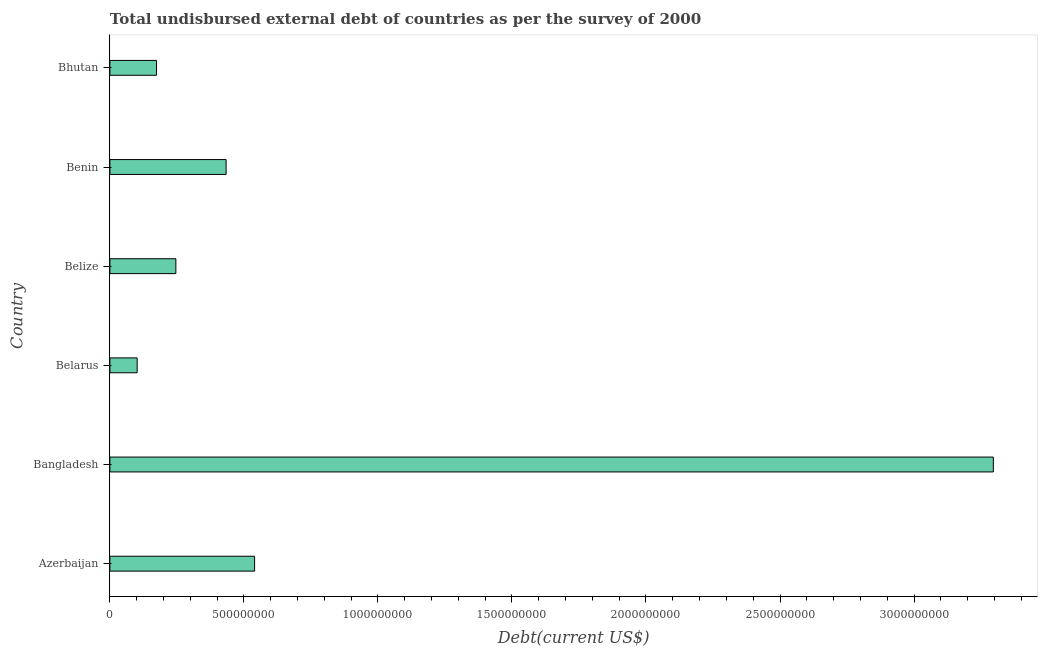What is the title of the graph?
Make the answer very short. Total undisbursed external debt of countries as per the survey of 2000. What is the label or title of the X-axis?
Keep it short and to the point. Debt(current US$). What is the total debt in Bangladesh?
Your response must be concise. 3.30e+09. Across all countries, what is the maximum total debt?
Your answer should be very brief. 3.30e+09. Across all countries, what is the minimum total debt?
Offer a terse response. 1.02e+08. In which country was the total debt minimum?
Make the answer very short. Belarus. What is the sum of the total debt?
Your answer should be compact. 4.79e+09. What is the difference between the total debt in Azerbaijan and Bhutan?
Offer a very short reply. 3.66e+08. What is the average total debt per country?
Your response must be concise. 7.99e+08. What is the median total debt?
Your answer should be very brief. 3.40e+08. In how many countries, is the total debt greater than 2600000000 US$?
Provide a succinct answer. 1. What is the ratio of the total debt in Bangladesh to that in Belize?
Give a very brief answer. 13.39. Is the difference between the total debt in Azerbaijan and Bhutan greater than the difference between any two countries?
Your answer should be compact. No. What is the difference between the highest and the second highest total debt?
Offer a terse response. 2.76e+09. What is the difference between the highest and the lowest total debt?
Your answer should be very brief. 3.19e+09. How many countries are there in the graph?
Provide a short and direct response. 6. What is the difference between two consecutive major ticks on the X-axis?
Your answer should be compact. 5.00e+08. Are the values on the major ticks of X-axis written in scientific E-notation?
Your response must be concise. No. What is the Debt(current US$) in Azerbaijan?
Provide a short and direct response. 5.40e+08. What is the Debt(current US$) of Bangladesh?
Provide a short and direct response. 3.30e+09. What is the Debt(current US$) of Belarus?
Offer a terse response. 1.02e+08. What is the Debt(current US$) in Belize?
Keep it short and to the point. 2.46e+08. What is the Debt(current US$) in Benin?
Your answer should be very brief. 4.34e+08. What is the Debt(current US$) in Bhutan?
Offer a very short reply. 1.74e+08. What is the difference between the Debt(current US$) in Azerbaijan and Bangladesh?
Your response must be concise. -2.76e+09. What is the difference between the Debt(current US$) in Azerbaijan and Belarus?
Ensure brevity in your answer.  4.38e+08. What is the difference between the Debt(current US$) in Azerbaijan and Belize?
Your answer should be compact. 2.94e+08. What is the difference between the Debt(current US$) in Azerbaijan and Benin?
Your response must be concise. 1.06e+08. What is the difference between the Debt(current US$) in Azerbaijan and Bhutan?
Offer a terse response. 3.66e+08. What is the difference between the Debt(current US$) in Bangladesh and Belarus?
Keep it short and to the point. 3.19e+09. What is the difference between the Debt(current US$) in Bangladesh and Belize?
Offer a terse response. 3.05e+09. What is the difference between the Debt(current US$) in Bangladesh and Benin?
Your answer should be very brief. 2.86e+09. What is the difference between the Debt(current US$) in Bangladesh and Bhutan?
Provide a short and direct response. 3.12e+09. What is the difference between the Debt(current US$) in Belarus and Belize?
Your response must be concise. -1.44e+08. What is the difference between the Debt(current US$) in Belarus and Benin?
Your answer should be compact. -3.32e+08. What is the difference between the Debt(current US$) in Belarus and Bhutan?
Your response must be concise. -7.22e+07. What is the difference between the Debt(current US$) in Belize and Benin?
Provide a short and direct response. -1.87e+08. What is the difference between the Debt(current US$) in Belize and Bhutan?
Your response must be concise. 7.22e+07. What is the difference between the Debt(current US$) in Benin and Bhutan?
Keep it short and to the point. 2.60e+08. What is the ratio of the Debt(current US$) in Azerbaijan to that in Bangladesh?
Give a very brief answer. 0.16. What is the ratio of the Debt(current US$) in Azerbaijan to that in Belarus?
Make the answer very short. 5.31. What is the ratio of the Debt(current US$) in Azerbaijan to that in Belize?
Your response must be concise. 2.19. What is the ratio of the Debt(current US$) in Azerbaijan to that in Benin?
Make the answer very short. 1.25. What is the ratio of the Debt(current US$) in Azerbaijan to that in Bhutan?
Make the answer very short. 3.1. What is the ratio of the Debt(current US$) in Bangladesh to that in Belarus?
Your answer should be compact. 32.4. What is the ratio of the Debt(current US$) in Bangladesh to that in Belize?
Offer a very short reply. 13.39. What is the ratio of the Debt(current US$) in Bangladesh to that in Benin?
Make the answer very short. 7.6. What is the ratio of the Debt(current US$) in Bangladesh to that in Bhutan?
Make the answer very short. 18.95. What is the ratio of the Debt(current US$) in Belarus to that in Belize?
Provide a short and direct response. 0.41. What is the ratio of the Debt(current US$) in Belarus to that in Benin?
Give a very brief answer. 0.23. What is the ratio of the Debt(current US$) in Belarus to that in Bhutan?
Provide a short and direct response. 0.58. What is the ratio of the Debt(current US$) in Belize to that in Benin?
Provide a short and direct response. 0.57. What is the ratio of the Debt(current US$) in Belize to that in Bhutan?
Your response must be concise. 1.42. What is the ratio of the Debt(current US$) in Benin to that in Bhutan?
Ensure brevity in your answer.  2.49. 